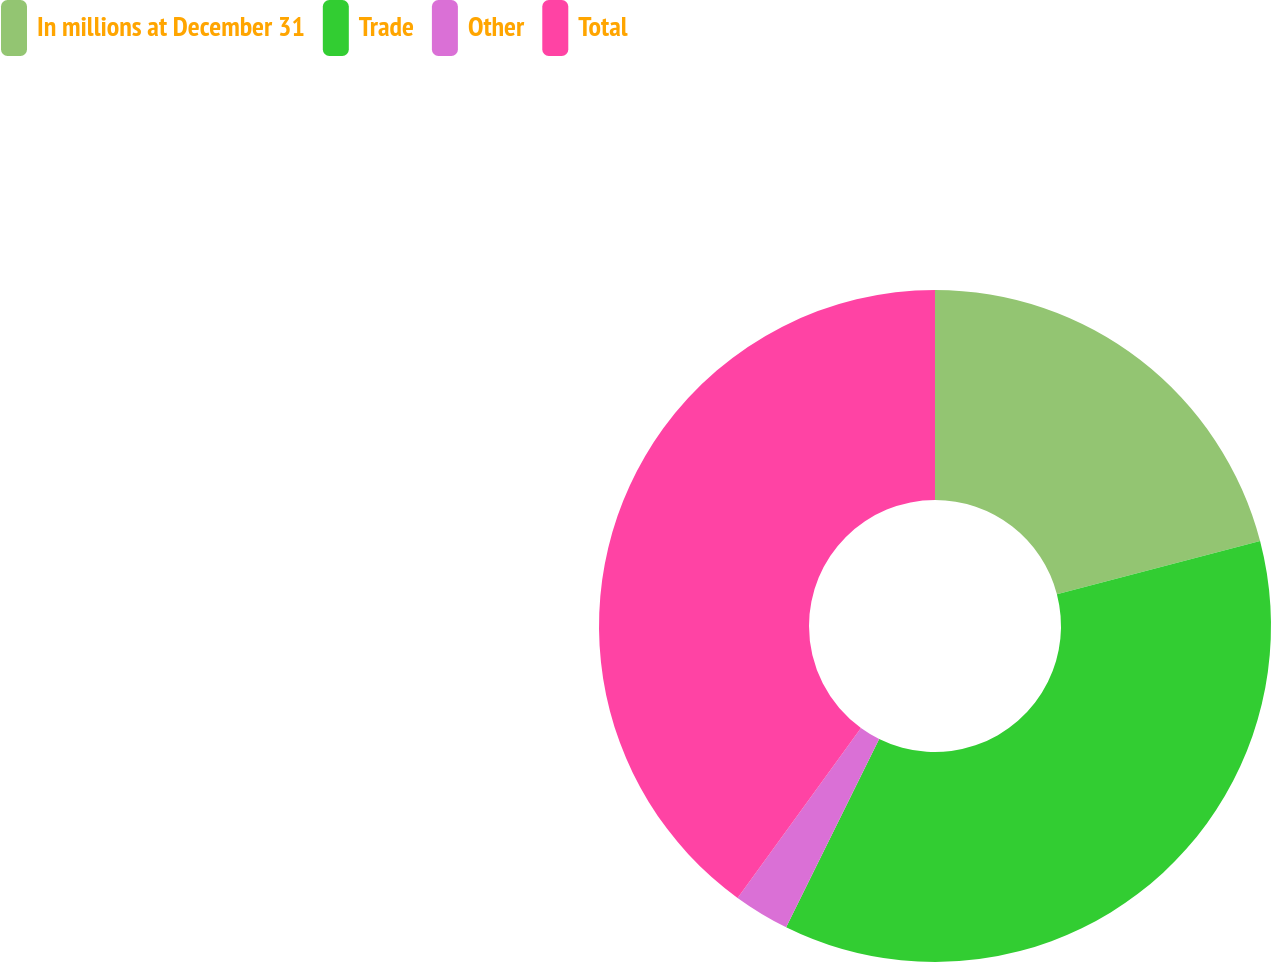Convert chart to OTSL. <chart><loc_0><loc_0><loc_500><loc_500><pie_chart><fcel>In millions at December 31<fcel>Trade<fcel>Other<fcel>Total<nl><fcel>20.93%<fcel>36.37%<fcel>2.69%<fcel>40.0%<nl></chart> 